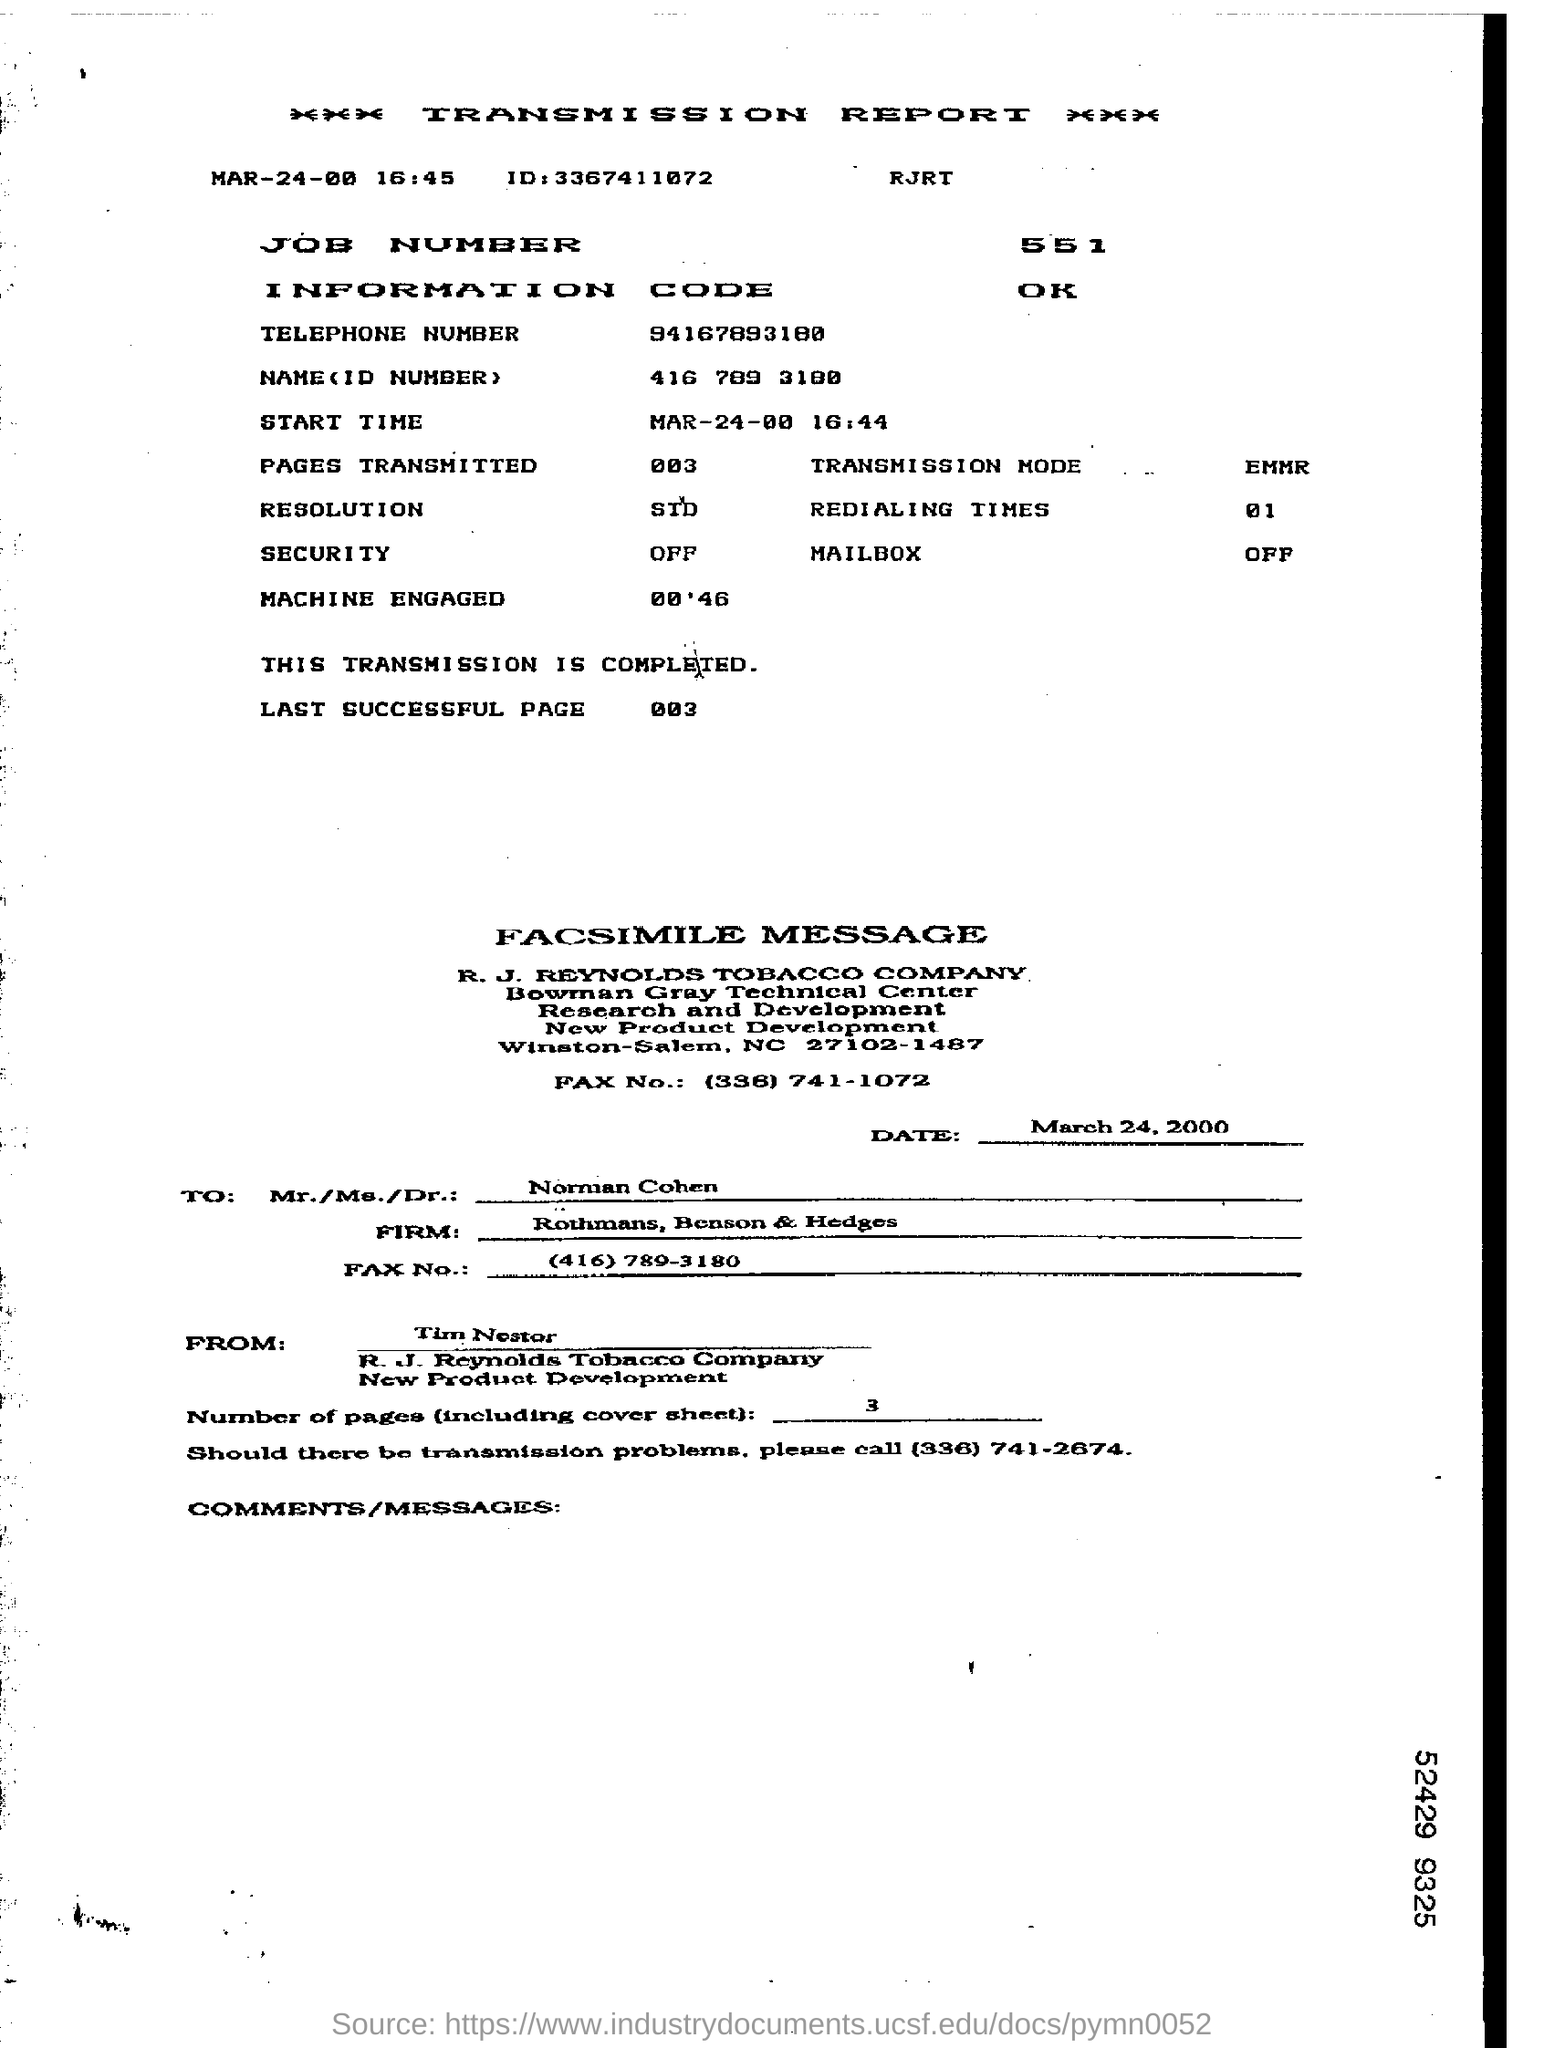Specify some key components in this picture. The fax is being sent to Norman Cohen. The transmission mode mentioned in the report is EMMR. The ID mentioned in the transmission report is 3367411072. The sender of the fax is Tim Nestor. The redialing times mentioned in the report are 01.. 